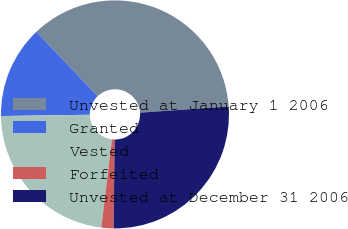Convert chart to OTSL. <chart><loc_0><loc_0><loc_500><loc_500><pie_chart><fcel>Unvested at January 1 2006<fcel>Granted<fcel>Vested<fcel>Forfeited<fcel>Unvested at December 31 2006<nl><fcel>36.0%<fcel>13.12%<fcel>22.86%<fcel>1.72%<fcel>26.29%<nl></chart> 